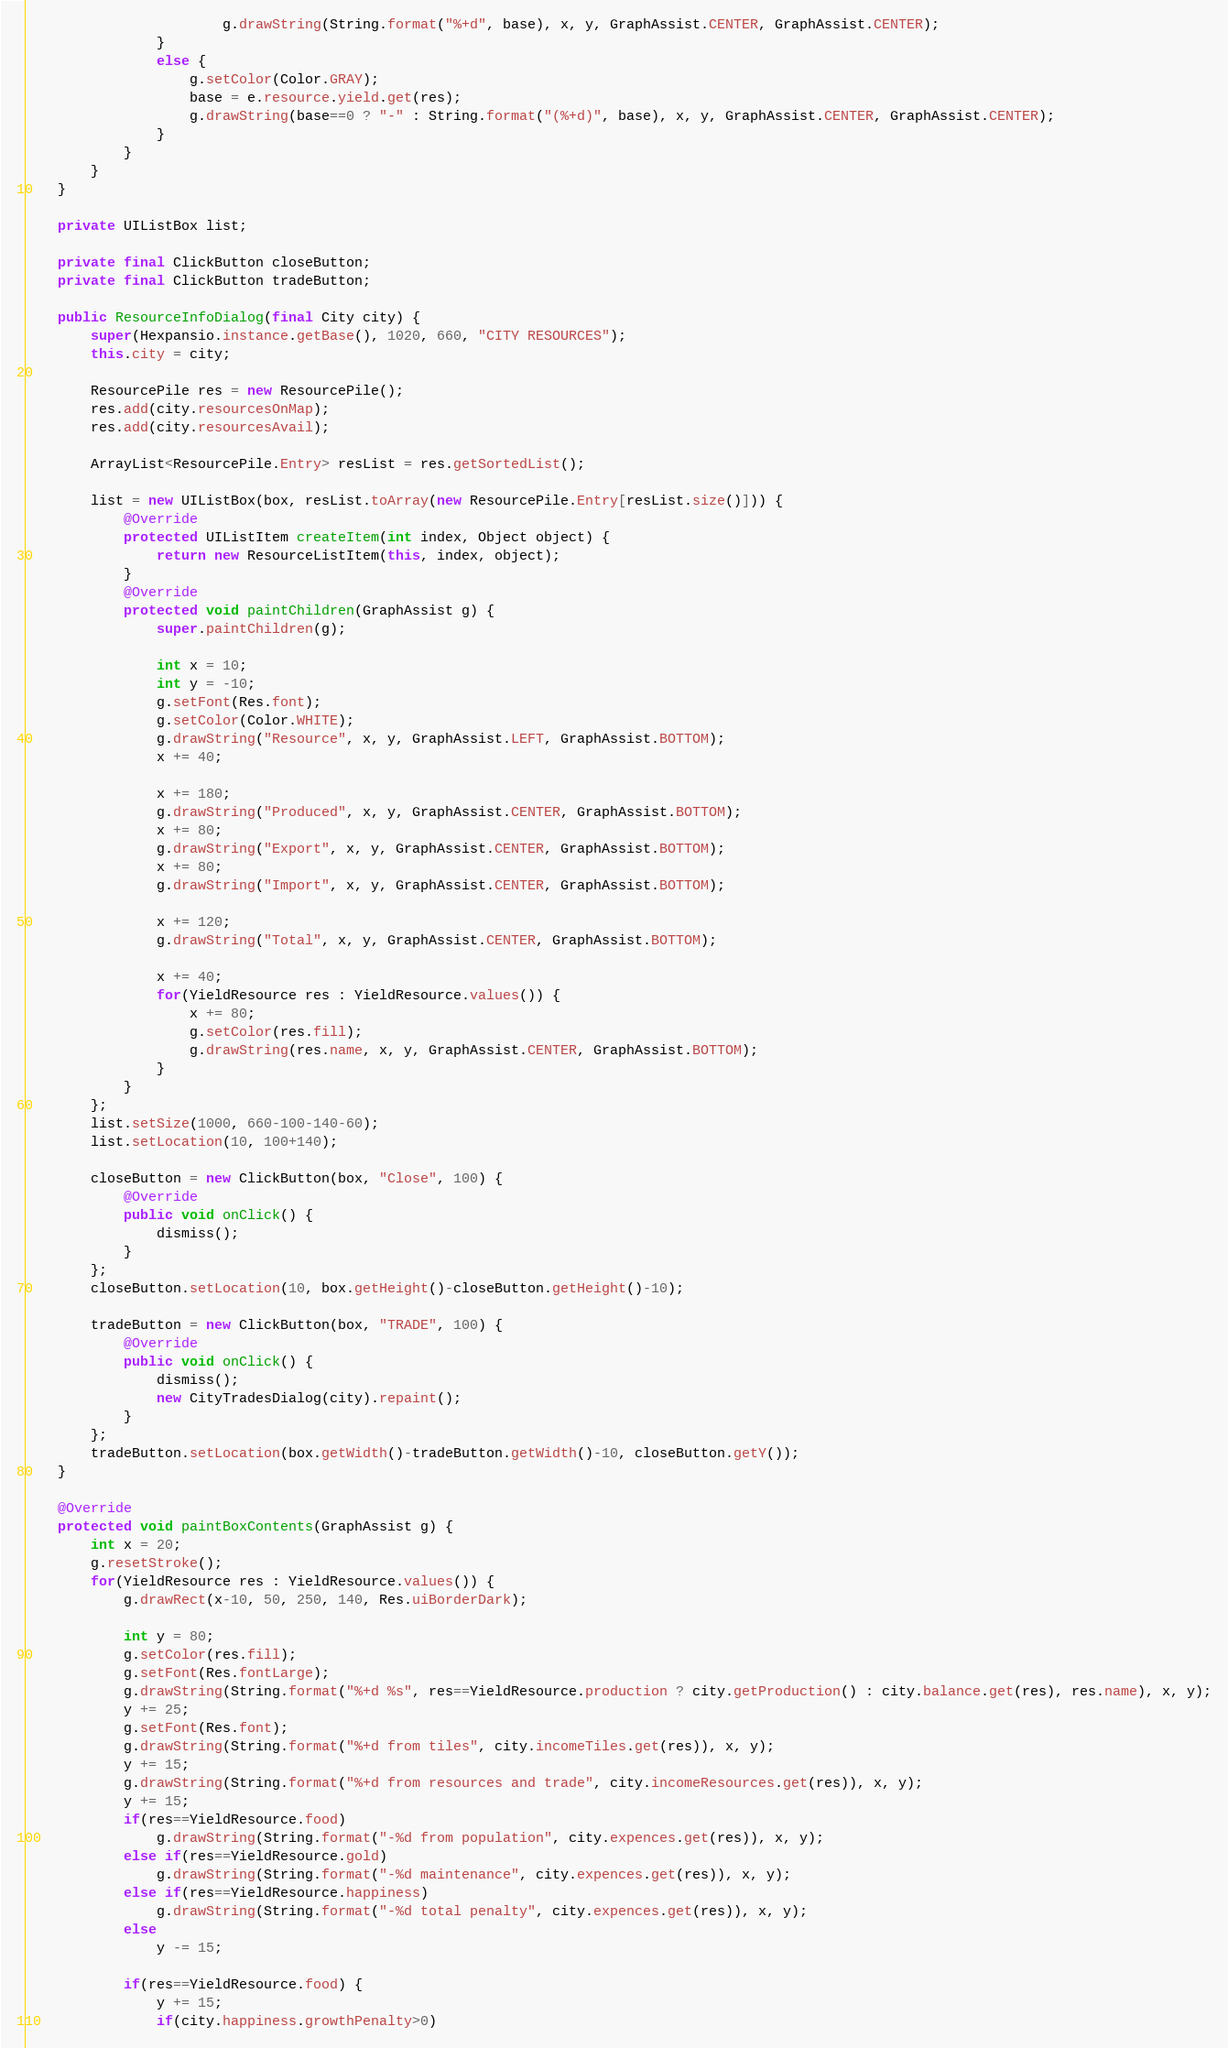Convert code to text. <code><loc_0><loc_0><loc_500><loc_500><_Java_>						g.drawString(String.format("%+d", base), x, y, GraphAssist.CENTER, GraphAssist.CENTER);
				}
				else {
					g.setColor(Color.GRAY);
					base = e.resource.yield.get(res);
					g.drawString(base==0 ? "-" : String.format("(%+d)", base), x, y, GraphAssist.CENTER, GraphAssist.CENTER);
				}
			}
		}
	}

	private UIListBox list;

	private final ClickButton closeButton;
	private final ClickButton tradeButton;

	public ResourceInfoDialog(final City city) {
		super(Hexpansio.instance.getBase(), 1020, 660, "CITY RESOURCES");
		this.city = city;
		
		ResourcePile res = new ResourcePile();
		res.add(city.resourcesOnMap);
		res.add(city.resourcesAvail);
		
		ArrayList<ResourcePile.Entry> resList = res.getSortedList();
		
		list = new UIListBox(box, resList.toArray(new ResourcePile.Entry[resList.size()])) {
			@Override
			protected UIListItem createItem(int index, Object object) {
				return new ResourceListItem(this, index, object);
			}
			@Override
			protected void paintChildren(GraphAssist g) {
				super.paintChildren(g);
				
				int x = 10;
				int y = -10;
				g.setFont(Res.font);
				g.setColor(Color.WHITE);
				g.drawString("Resource", x, y, GraphAssist.LEFT, GraphAssist.BOTTOM);
				x += 40;

				x += 180;
				g.drawString("Produced", x, y, GraphAssist.CENTER, GraphAssist.BOTTOM);
				x += 80;
				g.drawString("Export", x, y, GraphAssist.CENTER, GraphAssist.BOTTOM);
				x += 80;
				g.drawString("Import", x, y, GraphAssist.CENTER, GraphAssist.BOTTOM);
				
				x += 120;
				g.drawString("Total", x, y, GraphAssist.CENTER, GraphAssist.BOTTOM);

				x += 40;
				for(YieldResource res : YieldResource.values()) {
					x += 80;
					g.setColor(res.fill);
					g.drawString(res.name, x, y, GraphAssist.CENTER, GraphAssist.BOTTOM);
				}
			}
		};
		list.setSize(1000, 660-100-140-60);
		list.setLocation(10, 100+140);
		
		closeButton = new ClickButton(box, "Close", 100) {
			@Override
			public void onClick() {
				dismiss();
			}
		};
		closeButton.setLocation(10, box.getHeight()-closeButton.getHeight()-10);
		
		tradeButton = new ClickButton(box, "TRADE", 100) {
			@Override
			public void onClick() {
				dismiss();
				new CityTradesDialog(city).repaint();
			}
		};
		tradeButton.setLocation(box.getWidth()-tradeButton.getWidth()-10, closeButton.getY());
	}

	@Override
	protected void paintBoxContents(GraphAssist g) {
		int x = 20;
		g.resetStroke();
		for(YieldResource res : YieldResource.values()) {
			g.drawRect(x-10, 50, 250, 140, Res.uiBorderDark);
			
			int y = 80;
			g.setColor(res.fill);
			g.setFont(Res.fontLarge);
			g.drawString(String.format("%+d %s", res==YieldResource.production ? city.getProduction() : city.balance.get(res), res.name), x, y);
			y += 25;
			g.setFont(Res.font);
			g.drawString(String.format("%+d from tiles", city.incomeTiles.get(res)), x, y);
			y += 15;
			g.drawString(String.format("%+d from resources and trade", city.incomeResources.get(res)), x, y);
			y += 15;
			if(res==YieldResource.food)
				g.drawString(String.format("-%d from population", city.expences.get(res)), x, y);
			else if(res==YieldResource.gold)
				g.drawString(String.format("-%d maintenance", city.expences.get(res)), x, y);
			else if(res==YieldResource.happiness)
				g.drawString(String.format("-%d total penalty", city.expences.get(res)), x, y);
			else
				y -= 15;

			if(res==YieldResource.food) {
				y += 15;
				if(city.happiness.growthPenalty>0)</code> 